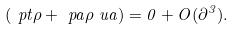Convert formula to latex. <formula><loc_0><loc_0><loc_500><loc_500>\left ( \ p t \rho + \ p a \rho \ u a \right ) = 0 + O ( \partial ^ { 3 } ) .</formula> 